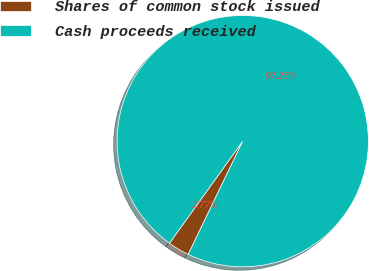Convert chart to OTSL. <chart><loc_0><loc_0><loc_500><loc_500><pie_chart><fcel>Shares of common stock issued<fcel>Cash proceeds received<nl><fcel>2.77%<fcel>97.23%<nl></chart> 